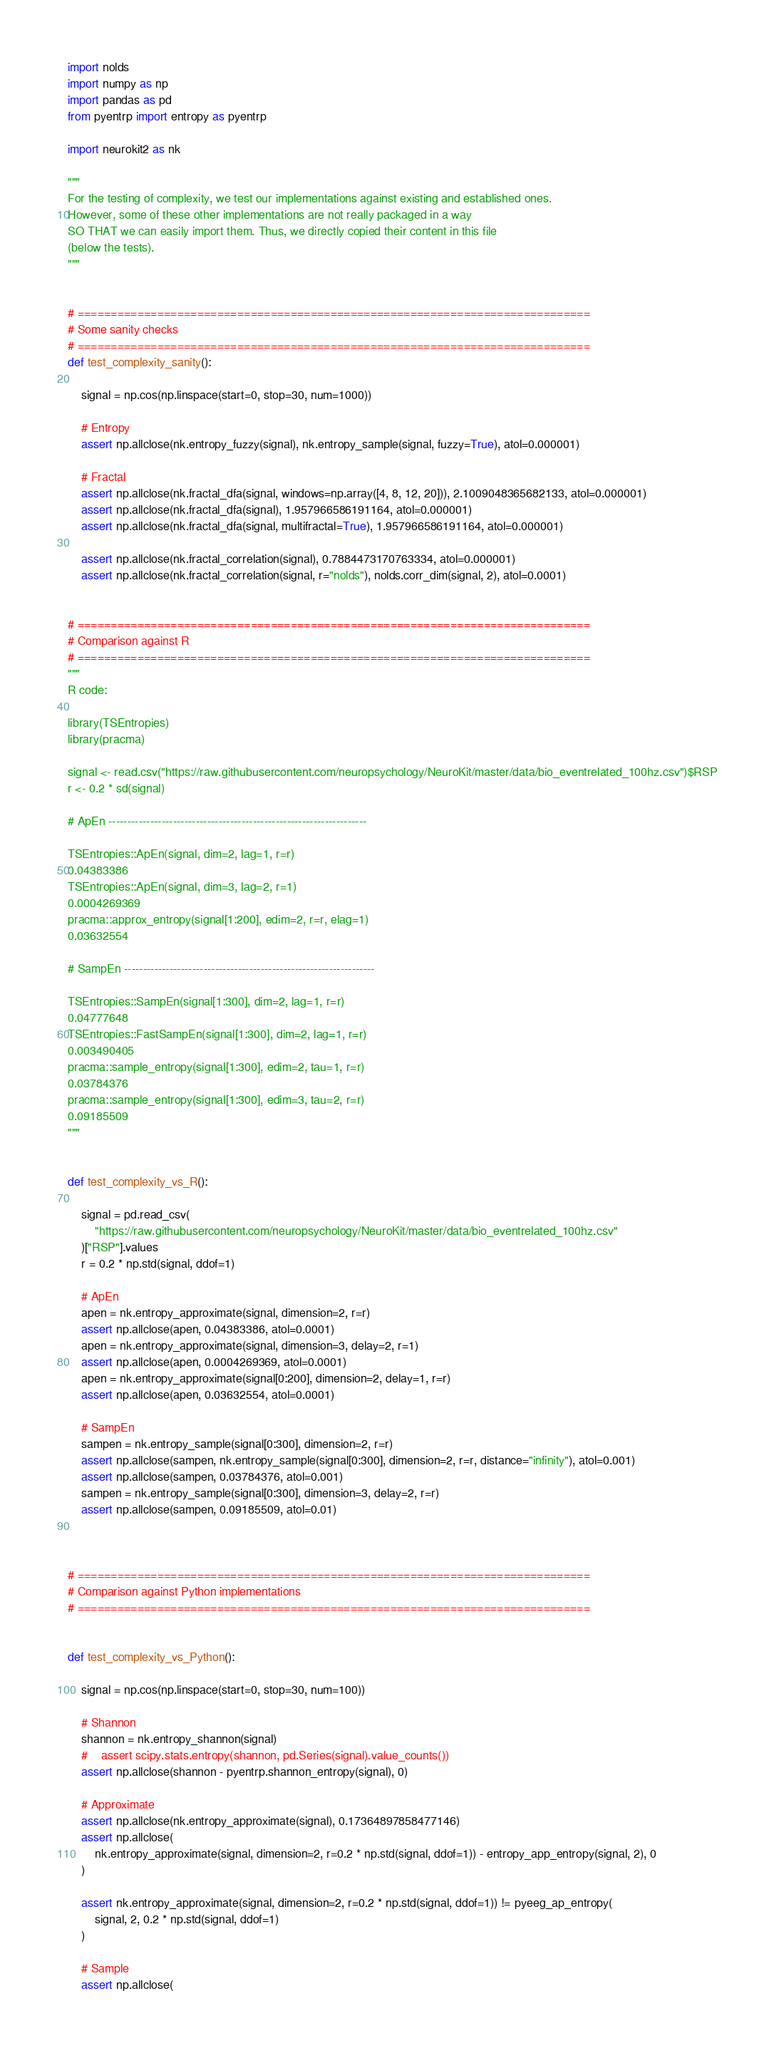Convert code to text. <code><loc_0><loc_0><loc_500><loc_500><_Python_>import nolds
import numpy as np
import pandas as pd
from pyentrp import entropy as pyentrp

import neurokit2 as nk

"""
For the testing of complexity, we test our implementations against existing and established ones.
However, some of these other implementations are not really packaged in a way
SO THAT we can easily import them. Thus, we directly copied their content in this file
(below the tests).
"""


# =============================================================================
# Some sanity checks
# =============================================================================
def test_complexity_sanity():

    signal = np.cos(np.linspace(start=0, stop=30, num=1000))

    # Entropy
    assert np.allclose(nk.entropy_fuzzy(signal), nk.entropy_sample(signal, fuzzy=True), atol=0.000001)

    # Fractal
    assert np.allclose(nk.fractal_dfa(signal, windows=np.array([4, 8, 12, 20])), 2.1009048365682133, atol=0.000001)
    assert np.allclose(nk.fractal_dfa(signal), 1.957966586191164, atol=0.000001)
    assert np.allclose(nk.fractal_dfa(signal, multifractal=True), 1.957966586191164, atol=0.000001)

    assert np.allclose(nk.fractal_correlation(signal), 0.7884473170763334, atol=0.000001)
    assert np.allclose(nk.fractal_correlation(signal, r="nolds"), nolds.corr_dim(signal, 2), atol=0.0001)


# =============================================================================
# Comparison against R
# =============================================================================
"""
R code:

library(TSEntropies)
library(pracma)

signal <- read.csv("https://raw.githubusercontent.com/neuropsychology/NeuroKit/master/data/bio_eventrelated_100hz.csv")$RSP
r <- 0.2 * sd(signal)

# ApEn --------------------------------------------------------------------

TSEntropies::ApEn(signal, dim=2, lag=1, r=r)
0.04383386
TSEntropies::ApEn(signal, dim=3, lag=2, r=1)
0.0004269369
pracma::approx_entropy(signal[1:200], edim=2, r=r, elag=1)
0.03632554

# SampEn ------------------------------------------------------------------

TSEntropies::SampEn(signal[1:300], dim=2, lag=1, r=r)
0.04777648
TSEntropies::FastSampEn(signal[1:300], dim=2, lag=1, r=r)
0.003490405
pracma::sample_entropy(signal[1:300], edim=2, tau=1, r=r)
0.03784376
pracma::sample_entropy(signal[1:300], edim=3, tau=2, r=r)
0.09185509
"""


def test_complexity_vs_R():

    signal = pd.read_csv(
        "https://raw.githubusercontent.com/neuropsychology/NeuroKit/master/data/bio_eventrelated_100hz.csv"
    )["RSP"].values
    r = 0.2 * np.std(signal, ddof=1)

    # ApEn
    apen = nk.entropy_approximate(signal, dimension=2, r=r)
    assert np.allclose(apen, 0.04383386, atol=0.0001)
    apen = nk.entropy_approximate(signal, dimension=3, delay=2, r=1)
    assert np.allclose(apen, 0.0004269369, atol=0.0001)
    apen = nk.entropy_approximate(signal[0:200], dimension=2, delay=1, r=r)
    assert np.allclose(apen, 0.03632554, atol=0.0001)

    # SampEn
    sampen = nk.entropy_sample(signal[0:300], dimension=2, r=r)
    assert np.allclose(sampen, nk.entropy_sample(signal[0:300], dimension=2, r=r, distance="infinity"), atol=0.001)
    assert np.allclose(sampen, 0.03784376, atol=0.001)
    sampen = nk.entropy_sample(signal[0:300], dimension=3, delay=2, r=r)
    assert np.allclose(sampen, 0.09185509, atol=0.01)



# =============================================================================
# Comparison against Python implementations
# =============================================================================


def test_complexity_vs_Python():

    signal = np.cos(np.linspace(start=0, stop=30, num=100))

    # Shannon
    shannon = nk.entropy_shannon(signal)
    #    assert scipy.stats.entropy(shannon, pd.Series(signal).value_counts())
    assert np.allclose(shannon - pyentrp.shannon_entropy(signal), 0)

    # Approximate
    assert np.allclose(nk.entropy_approximate(signal), 0.17364897858477146)
    assert np.allclose(
        nk.entropy_approximate(signal, dimension=2, r=0.2 * np.std(signal, ddof=1)) - entropy_app_entropy(signal, 2), 0
    )

    assert nk.entropy_approximate(signal, dimension=2, r=0.2 * np.std(signal, ddof=1)) != pyeeg_ap_entropy(
        signal, 2, 0.2 * np.std(signal, ddof=1)
    )

    # Sample
    assert np.allclose(</code> 